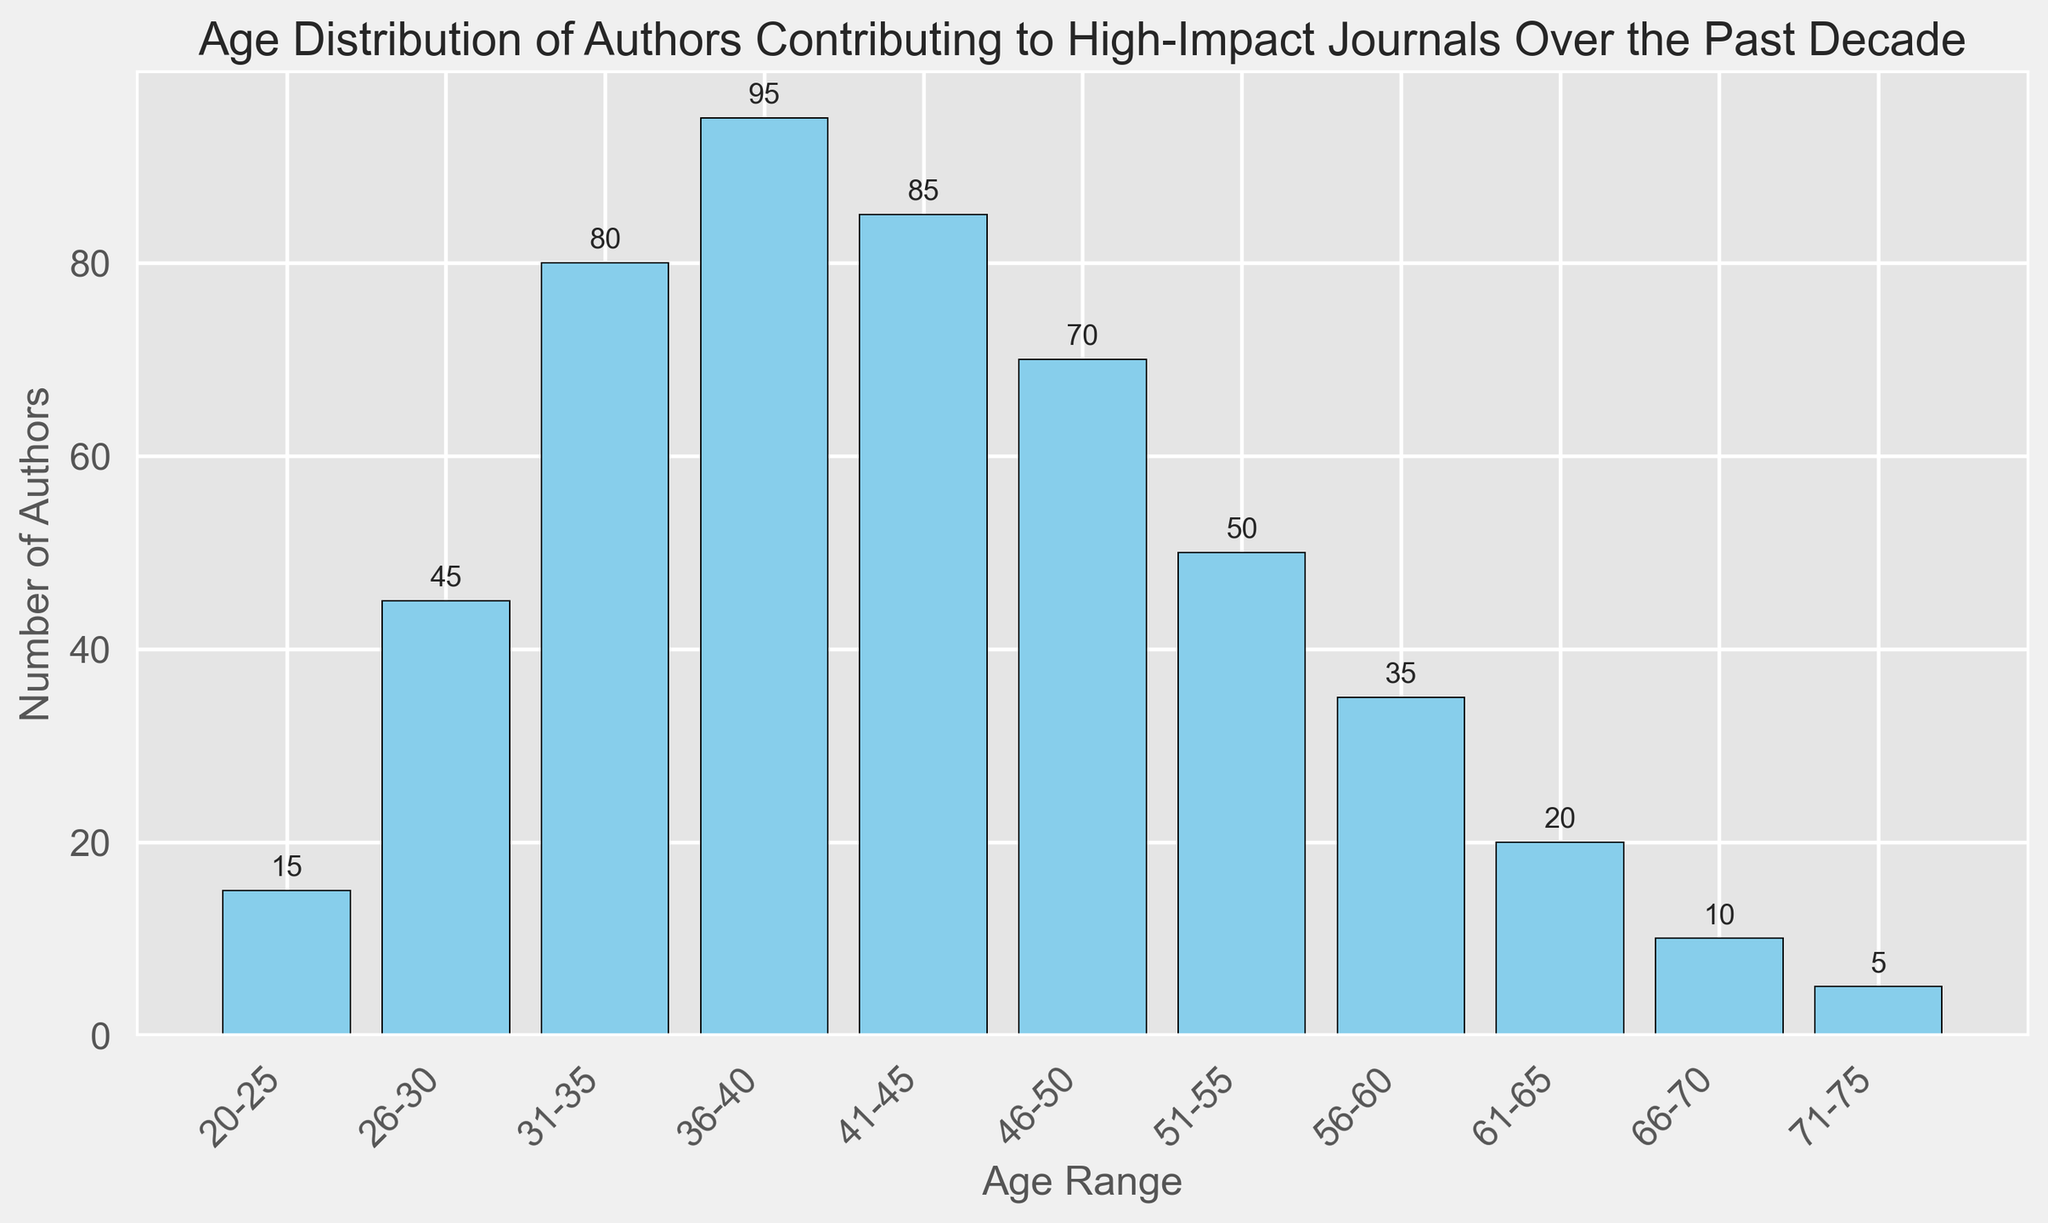What age range has the highest number of authors? To determine this, look for the tallest bar in the histogram. The bar representing ages 36-40 is the tallest with a height of 95.
Answer: 36-40 Which age range has the least number of authors? Identify the shortest bar in the histogram. The bar representing ages 71-75 is the shortest with a height of 5.
Answer: 71-75 What is the total number of authors in the age ranges 20-25 and 66-70 combined? Sum the counts for the age ranges 20-25 and 66-70. These counts are 15 and 10 respectively, so 15 + 10 = 25.
Answer: 25 How many more authors are there in the 41-45 age range compared to the 56-60 age range? Find the difference in counts between the two age ranges. The counts are 85 for 41-45 and 35 for 56-60, so 85 - 35 = 50.
Answer: 50 What is the average number of authors across all age ranges? Calculate the total number of authors and divide by the number of age ranges. The total is 15 + 45 + 80 + 95 + 85 + 70 + 50 + 35 + 20 + 10 + 5 = 510. There are 11 age ranges, so 510 / 11 ≈ 46.36.
Answer: 46.36 What percentage of the authors are aged between 36-40? To find this, divide the number of authors aged 36-40 by the total number of authors and multiply by 100. There are 95 authors in this range out of 510 total, so (95 / 510) * 100 ≈ 18.63%.
Answer: 18.63% Are there more authors aged between 51-55 or 61-65? Compare the heights of the bars for these age ranges. The 51-55 range has 50 authors, while the 61-65 range has 20 authors. Therefore, there are more authors aged 51-55.
Answer: 51-55 What is the range in the number of authors across the different age groups? Subtract the smallest count from the largest count. The largest count is 95 (36-40), and the smallest count is 5 (71-75), so 95 - 5 = 90.
Answer: 90 If you were to combine the authors in the age ranges 46-50 and 51-55, how would their total count compare to the number of authors in the 41-45 age range? Calculate the combined count for 46-50 and 51-55, and compare it to 41-45. The counts are 70 (46-50) and 50 (51-55), so 70 + 50 = 120 compared to 85 (41-45). Therefore, the combined count is higher by 120 - 85 = 35.
Answer: Higher by 35 